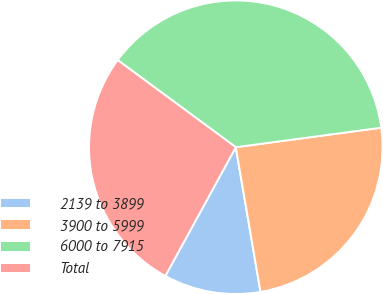Convert chart. <chart><loc_0><loc_0><loc_500><loc_500><pie_chart><fcel>2139 to 3899<fcel>3900 to 5999<fcel>6000 to 7915<fcel>Total<nl><fcel>10.66%<fcel>24.43%<fcel>37.76%<fcel>27.14%<nl></chart> 